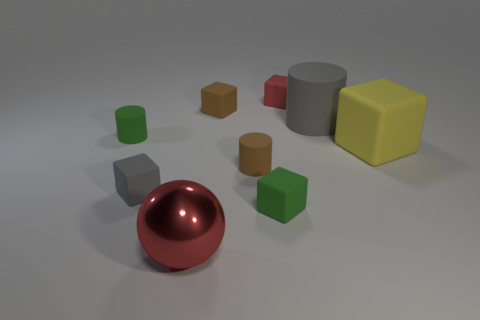Are there the same number of gray matte cylinders that are on the left side of the brown matte block and large gray rubber balls? Yes, both the set of gray matte cylinders to the left of the brown matte block and the set of large gray rubber balls comprise the same quantity, reinforcing the visual balance within the image. 